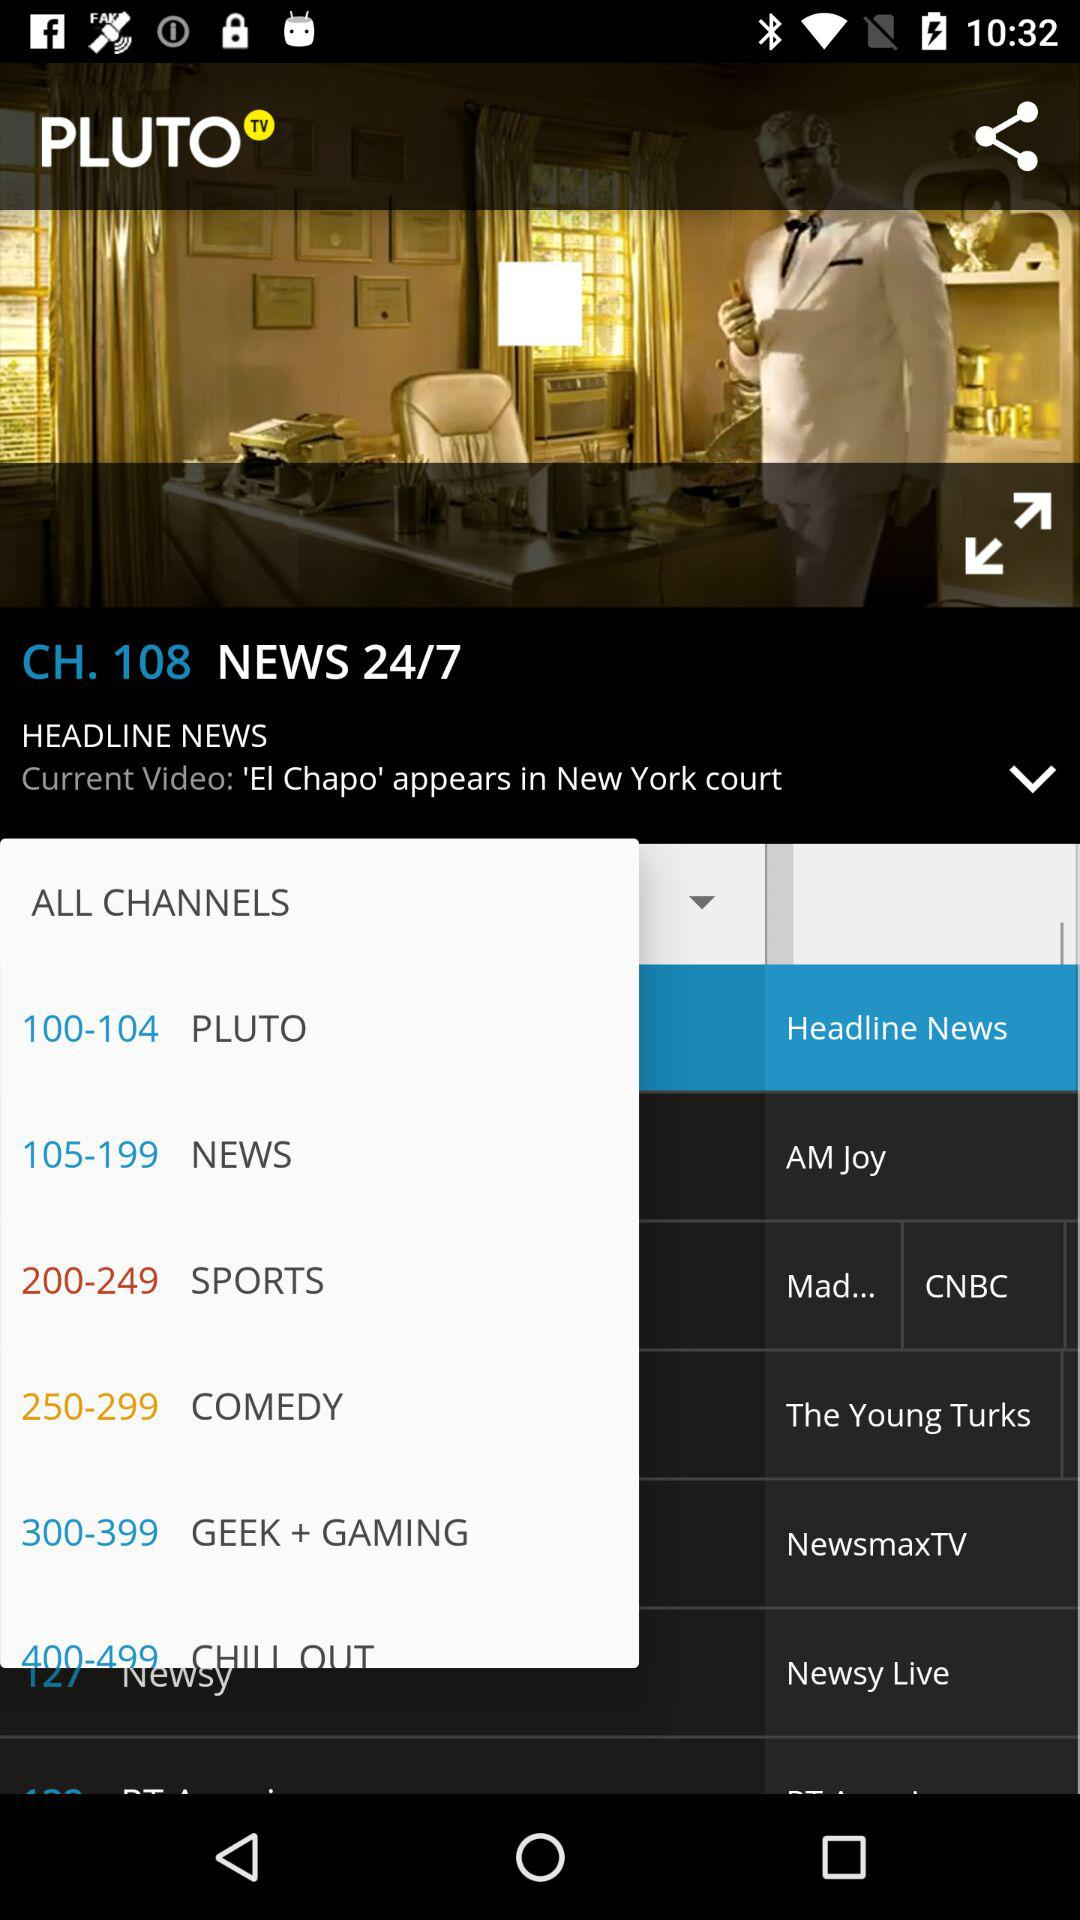What is the channel name? The channel name is "PLUTO TV". 